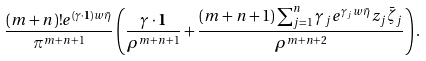Convert formula to latex. <formula><loc_0><loc_0><loc_500><loc_500>\frac { ( m + n ) ! e ^ { ( \gamma \cdot \mathbf 1 ) w \bar { \eta } } } { \pi ^ { m + n + 1 } } \left ( \frac { \gamma \cdot \mathbf 1 } { \rho ^ { m + n + 1 } } + \frac { ( m + n + 1 ) \sum _ { j = 1 } ^ { n } \gamma _ { j } e ^ { \gamma _ { j } w \bar { \eta } } z _ { j } \bar { \zeta } _ { j } } { \rho ^ { m + n + 2 } } \right ) .</formula> 